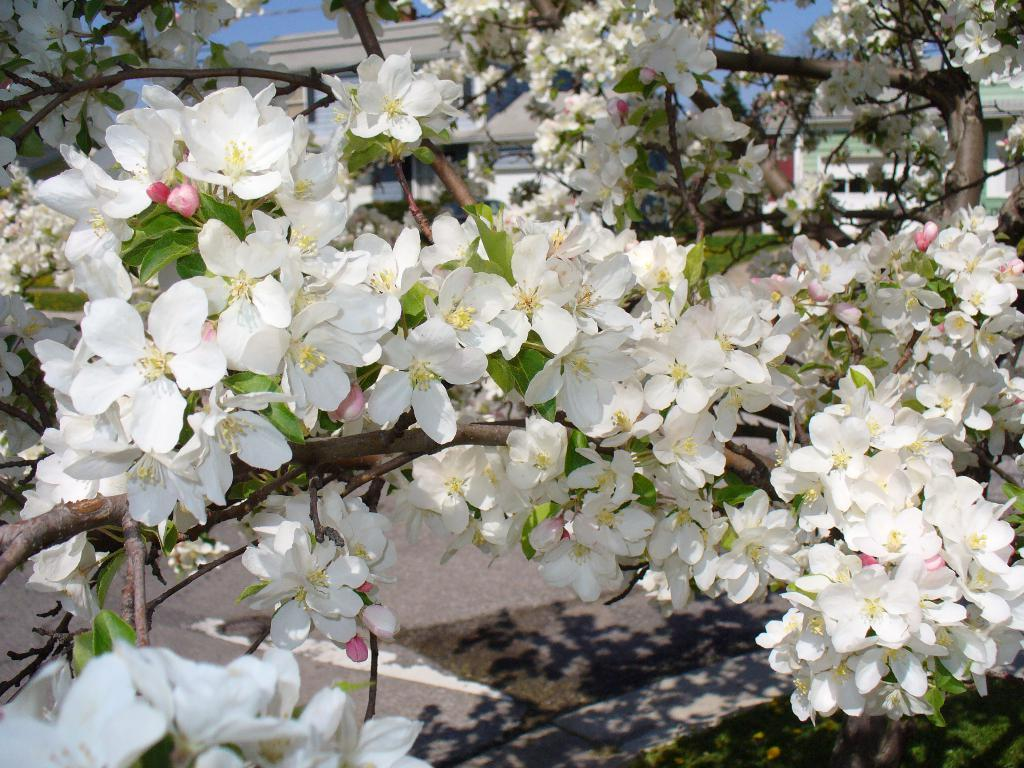What is the main subject of the image? A: The main subject of the image is a tree. Can you describe the colors of the tree? The tree has green and brown colors. What additional features can be seen on the tree? The tree has flowers that are white and pink in color. What can be seen in the background of the image? There are buildings and the sky visible in the background of the image. What is your opinion on the button that is attached to the star in the image? There is no button or star present in the image; it features a tree with flowers and a background of buildings and the sky. 